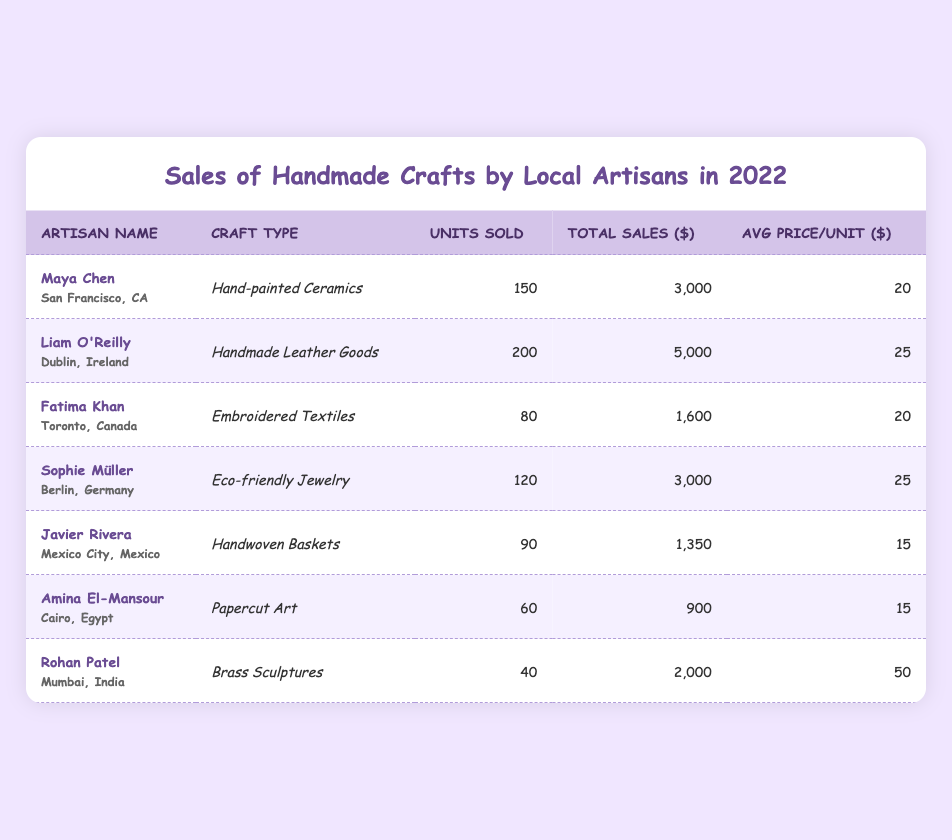What was the total sales amount for Liam O'Reilly? According to the table, the total sales amount for Liam O'Reilly is listed directly in the Total Sales column next to his name, which shows "$5,000".
Answer: 5000 Which artisan sold the most units overall? To find out, we compare the Units Sold column for all artisans. The highest number of units sold is 200, which belongs to Liam O'Reilly.
Answer: Liam O'Reilly Is the average price for Amina El-Mansour's papercut art higher than the average price for Javier Rivera's handwoven baskets? Amina El-Mansour has an average price of $15 for her papercut art, and Javier Rivera has an average price of $15 for his handwoven baskets. Therefore, the averages are equal, so the answer is no.
Answer: No What is the total number of units sold by all artisans combined? We sum the Units Sold for all artisans: 150 + 200 + 80 + 120 + 90 + 60 + 40 = 730. Thus, the total number of units sold by all artisans combined is 730.
Answer: 730 Did any artisan achieve total sales exceeding $3,000? By checking the Total Sales column, we see that both Liam O'Reilly ($5,000) and Sophie Müller ($3,000) have sales amounts equal to or greater than $3,000. Thus, the answer is yes.
Answer: Yes What is the average price per unit for all artisans? To calculate the average price per unit, we sum all average prices (20 + 25 + 20 + 25 + 15 + 15 + 50 = 170) and divide by the number of artisans (7): 170/7 = approximately 24.29.
Answer: Approximately 24.29 How many units did Fatima Khan sell compared to Maya Chen? Fatima Khan sold 80 units, while Maya Chen sold 150 units. Maya Chen sold more than Fatima Khan by 150 - 80 = 70 units.
Answer: Maya Chen sold 70 more units What craft type generated the highest total sales? Checking the Total Sales column, Liam O'Reilly's Handmade Leather Goods generated $5,000, which is the highest among all entries in the table.
Answer: Handmade Leather Goods Was Rohan Patel's average price per unit the highest among all artisans? Rohan Patel’s average price is $50, comparing with others, none have an average higher than $50, confirming he has the highest average price per unit.
Answer: Yes 